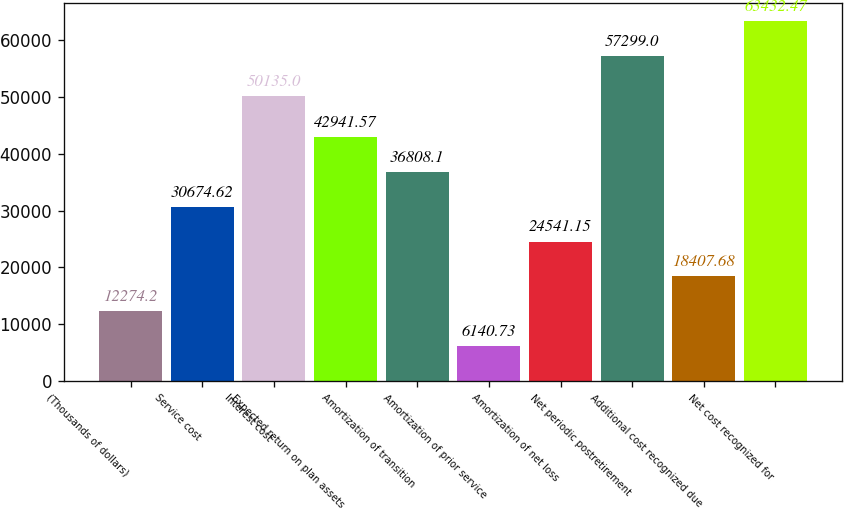<chart> <loc_0><loc_0><loc_500><loc_500><bar_chart><fcel>(Thousands of dollars)<fcel>Service cost<fcel>Interest cost<fcel>Expected return on plan assets<fcel>Amortization of transition<fcel>Amortization of prior service<fcel>Amortization of net loss<fcel>Net periodic postretirement<fcel>Additional cost recognized due<fcel>Net cost recognized for<nl><fcel>12274.2<fcel>30674.6<fcel>50135<fcel>42941.6<fcel>36808.1<fcel>6140.73<fcel>24541.2<fcel>57299<fcel>18407.7<fcel>63432.5<nl></chart> 